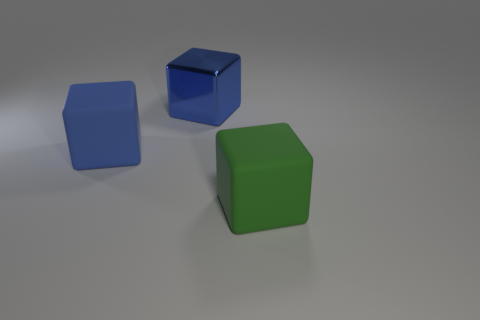There is a large object that is behind the big matte object that is to the left of the big green matte cube; what number of metal blocks are left of it? 0 